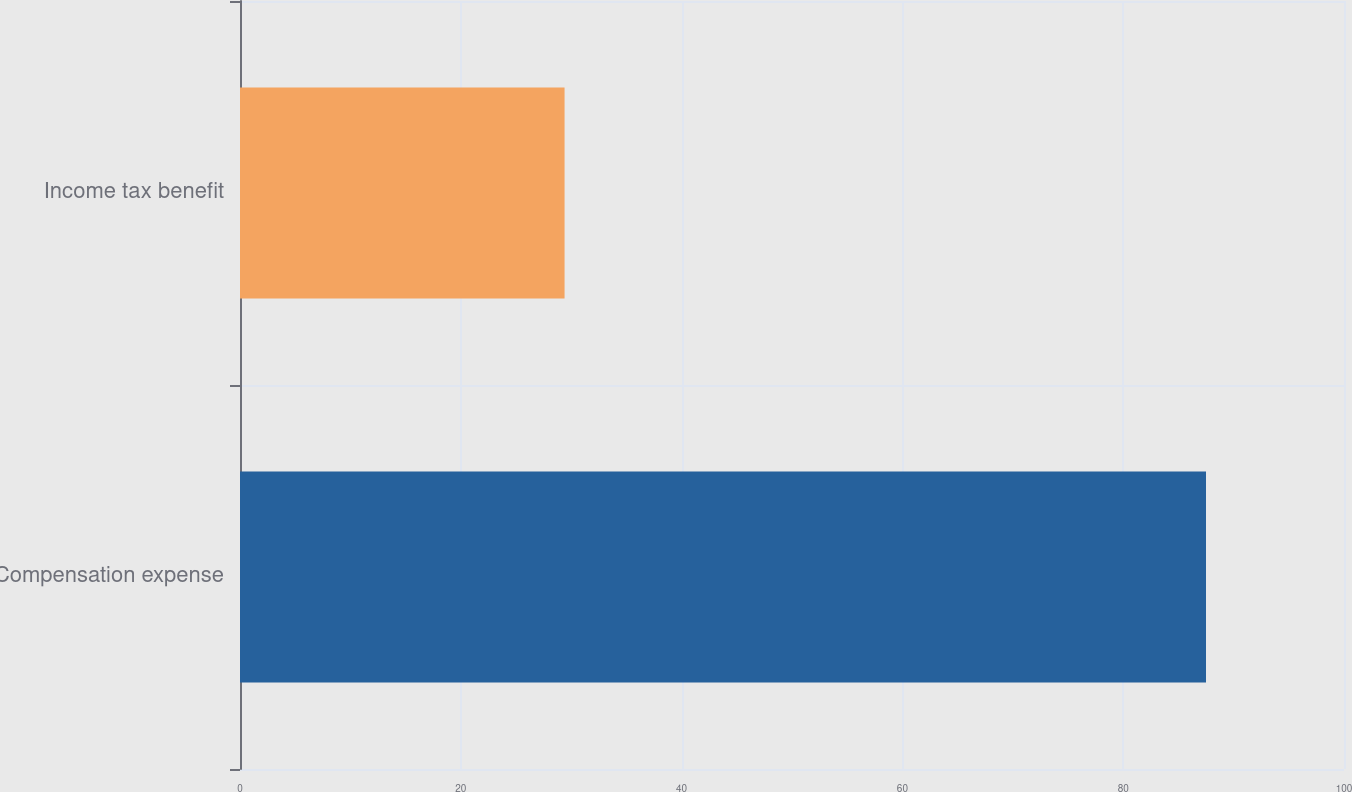Convert chart. <chart><loc_0><loc_0><loc_500><loc_500><bar_chart><fcel>Compensation expense<fcel>Income tax benefit<nl><fcel>87.5<fcel>29.4<nl></chart> 